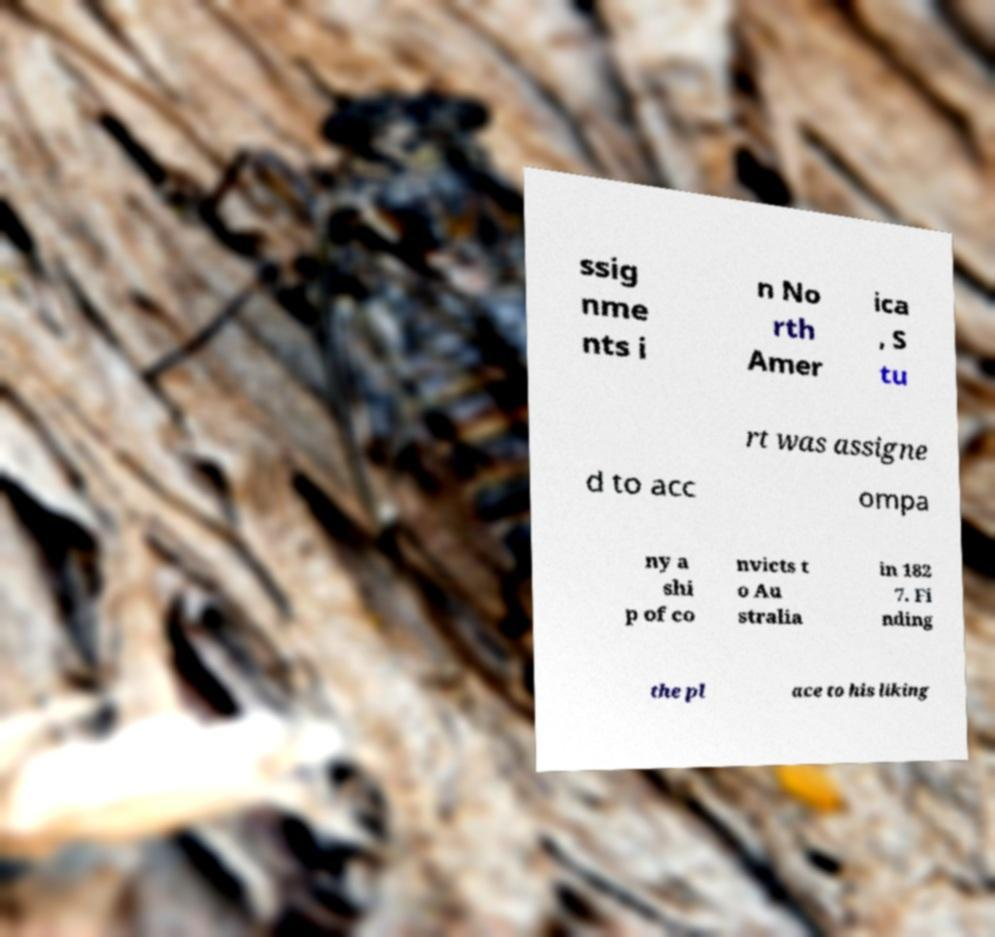Could you extract and type out the text from this image? ssig nme nts i n No rth Amer ica , S tu rt was assigne d to acc ompa ny a shi p of co nvicts t o Au stralia in 182 7. Fi nding the pl ace to his liking 